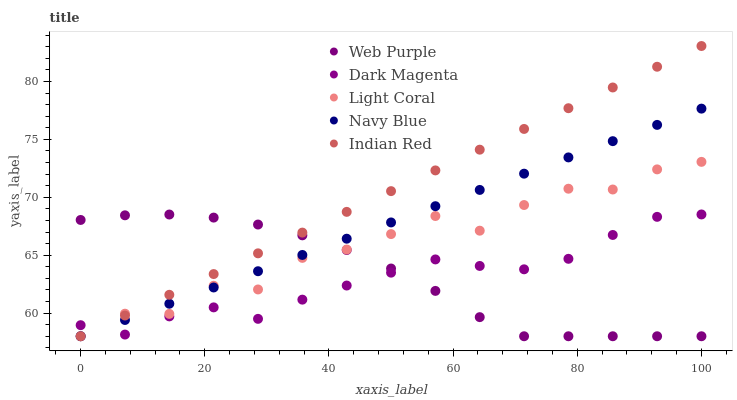Does Dark Magenta have the minimum area under the curve?
Answer yes or no. Yes. Does Indian Red have the maximum area under the curve?
Answer yes or no. Yes. Does Navy Blue have the minimum area under the curve?
Answer yes or no. No. Does Navy Blue have the maximum area under the curve?
Answer yes or no. No. Is Indian Red the smoothest?
Answer yes or no. Yes. Is Light Coral the roughest?
Answer yes or no. Yes. Is Navy Blue the smoothest?
Answer yes or no. No. Is Navy Blue the roughest?
Answer yes or no. No. Does Light Coral have the lowest value?
Answer yes or no. Yes. Does Dark Magenta have the lowest value?
Answer yes or no. No. Does Indian Red have the highest value?
Answer yes or no. Yes. Does Navy Blue have the highest value?
Answer yes or no. No. Does Web Purple intersect Light Coral?
Answer yes or no. Yes. Is Web Purple less than Light Coral?
Answer yes or no. No. Is Web Purple greater than Light Coral?
Answer yes or no. No. 